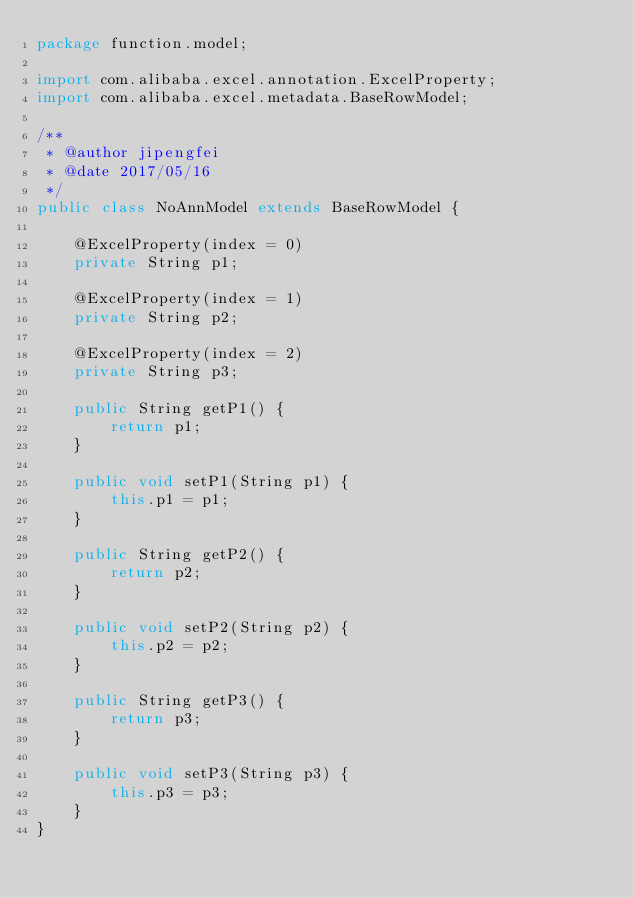Convert code to text. <code><loc_0><loc_0><loc_500><loc_500><_Java_>package function.model;

import com.alibaba.excel.annotation.ExcelProperty;
import com.alibaba.excel.metadata.BaseRowModel;

/**
 * @author jipengfei
 * @date 2017/05/16
 */
public class NoAnnModel extends BaseRowModel {

    @ExcelProperty(index = 0)
    private String p1;

    @ExcelProperty(index = 1)
    private String p2;

    @ExcelProperty(index = 2)
    private String p3;

    public String getP1() {
        return p1;
    }

    public void setP1(String p1) {
        this.p1 = p1;
    }

    public String getP2() {
        return p2;
    }

    public void setP2(String p2) {
        this.p2 = p2;
    }

    public String getP3() {
        return p3;
    }

    public void setP3(String p3) {
        this.p3 = p3;
    }
}
</code> 